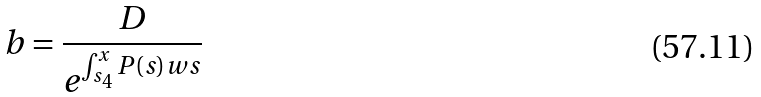<formula> <loc_0><loc_0><loc_500><loc_500>b = \frac { D } { e ^ { \int _ { s _ { 4 } } ^ { x } P ( s ) w s } }</formula> 